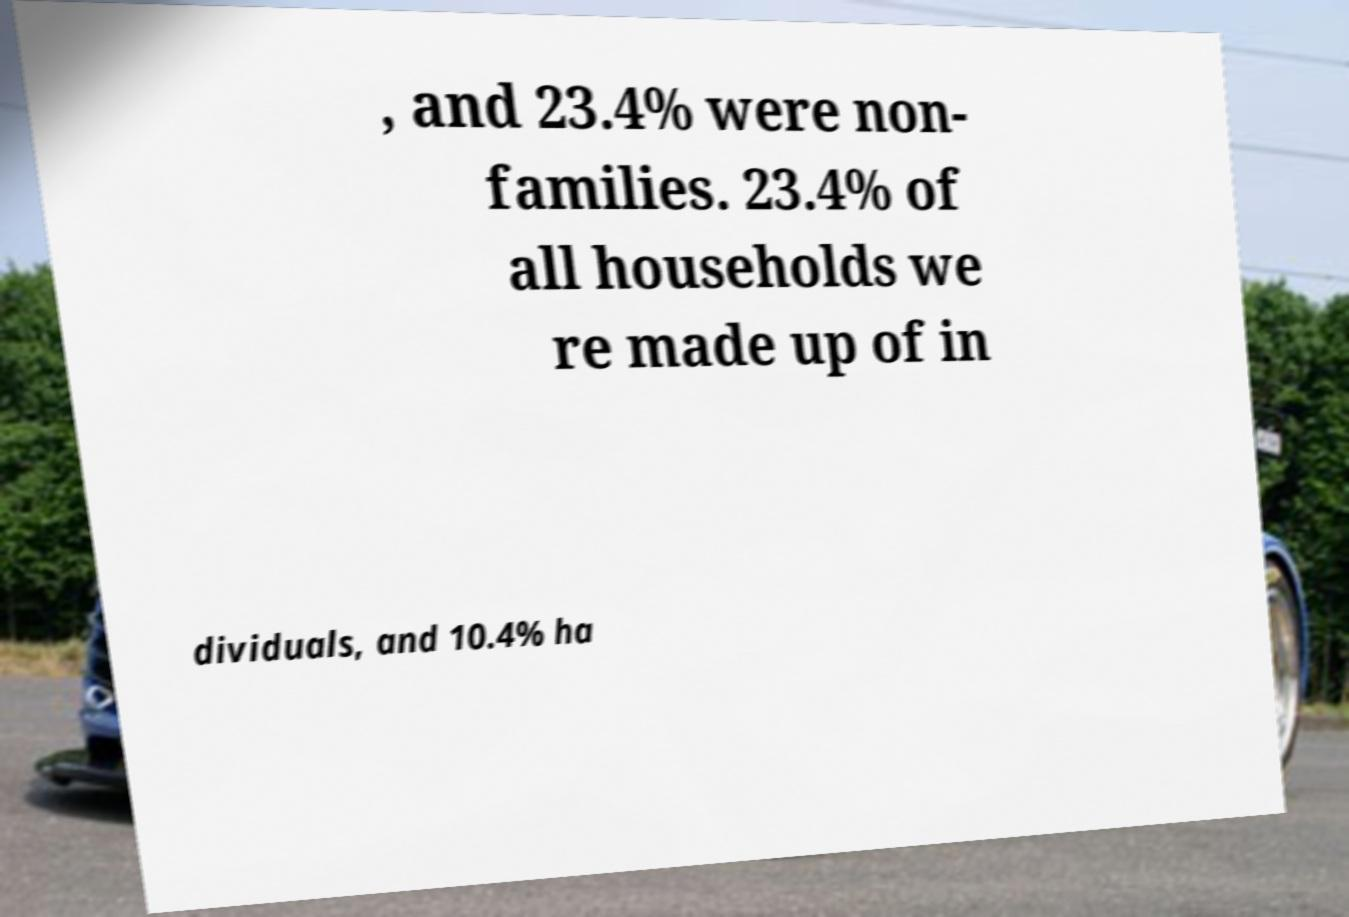Please identify and transcribe the text found in this image. , and 23.4% were non- families. 23.4% of all households we re made up of in dividuals, and 10.4% ha 